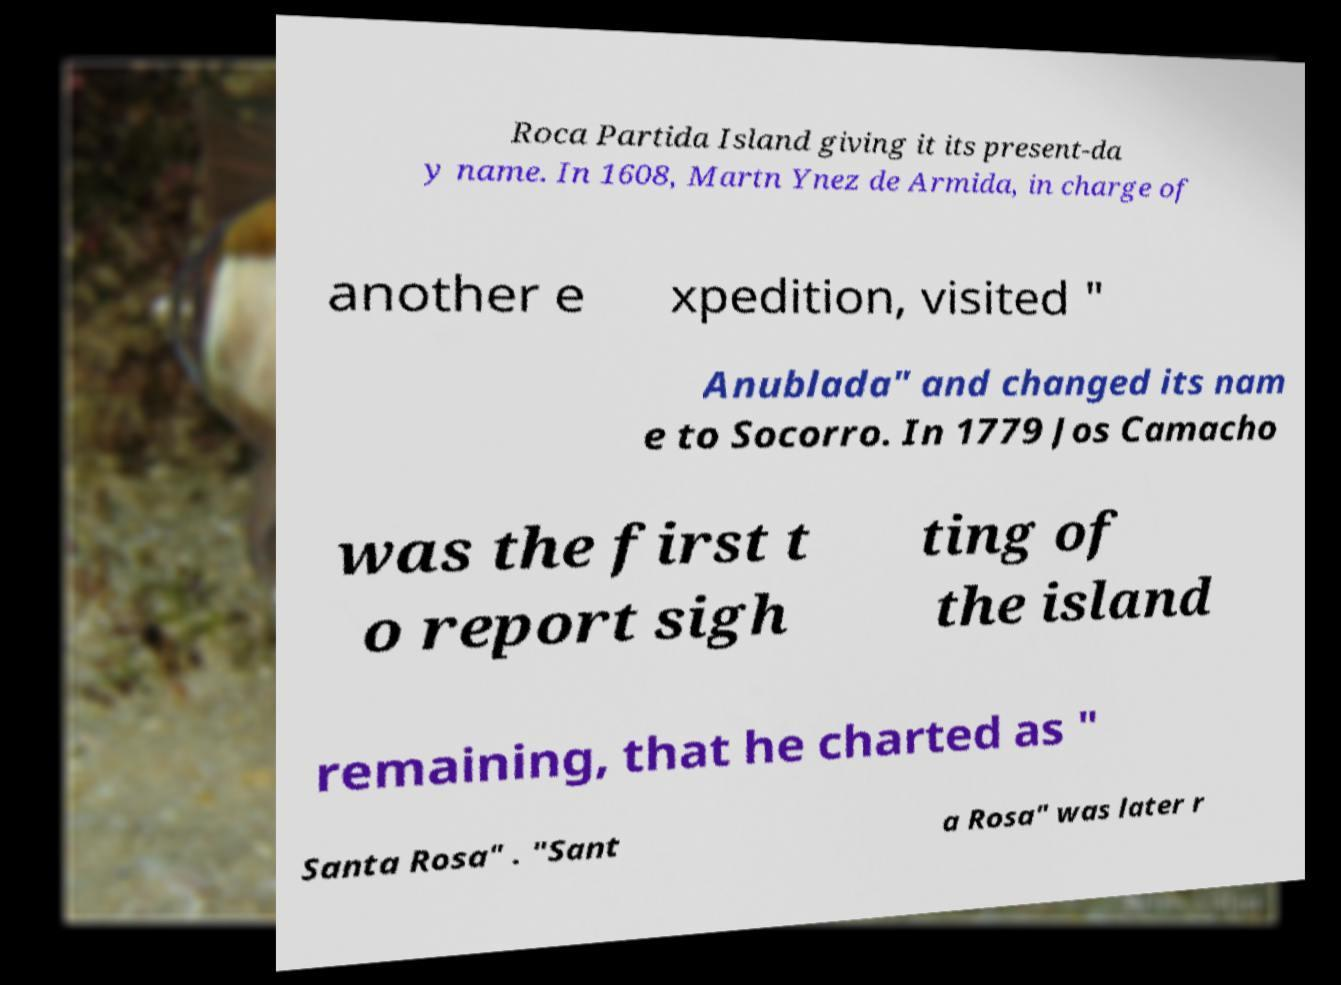Please read and relay the text visible in this image. What does it say? Roca Partida Island giving it its present-da y name. In 1608, Martn Ynez de Armida, in charge of another e xpedition, visited " Anublada" and changed its nam e to Socorro. In 1779 Jos Camacho was the first t o report sigh ting of the island remaining, that he charted as " Santa Rosa" . "Sant a Rosa" was later r 